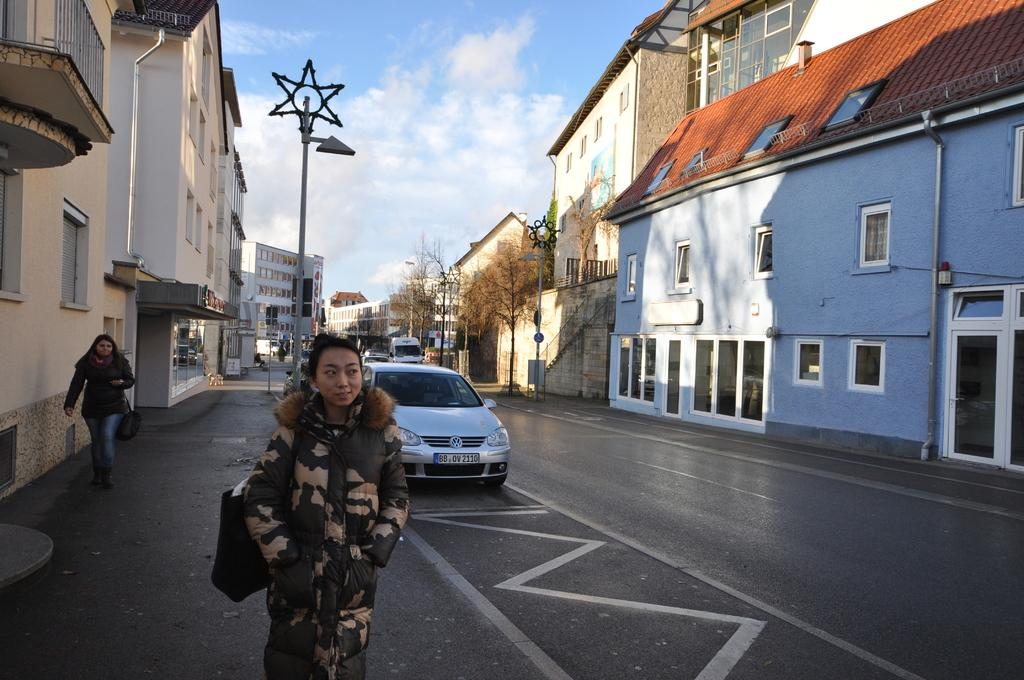How many people are in the image? There are two persons in the image. What else can be seen in the image besides the people? There are vehicles on the road, buildings, trees, and clouds in the sky in the image. What is the purpose of the star symbol attached to the street lights? The star symbol attached to the street lights is not mentioned in the facts, so we cannot determine its purpose. What type of environment is depicted in the image? The image shows an urban environment with buildings, roads, and street lights. Can you see a rabbit hopping on the ocean floor in the image? No, there is no rabbit or ocean floor present in the image. 